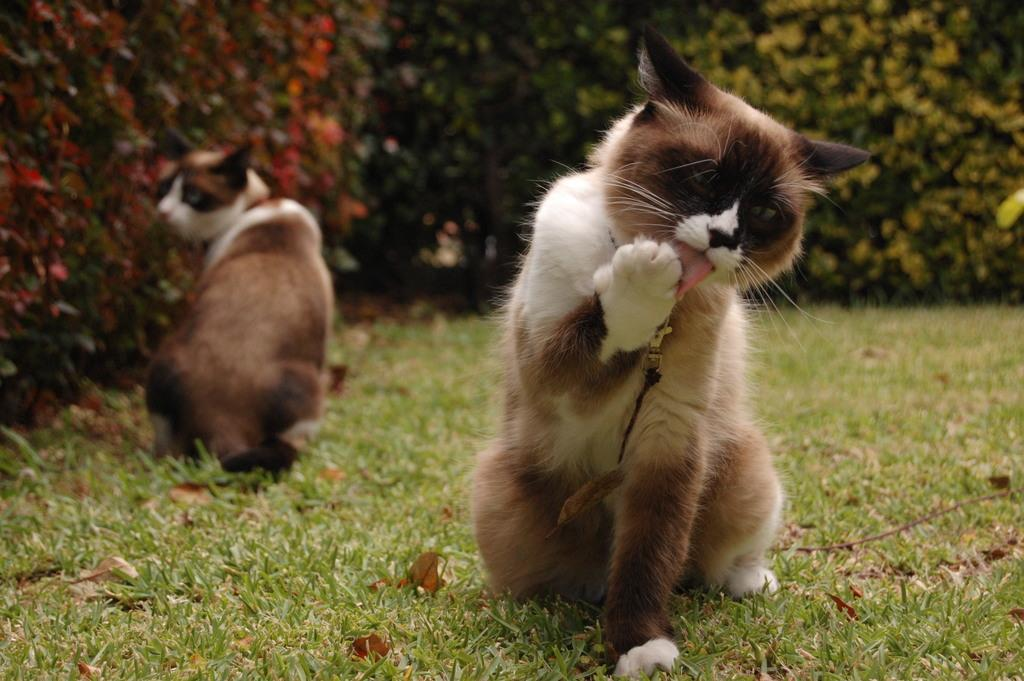What animals can be seen on the ground in the image? There are two cats on the ground in the image. What can be seen in the background of the image? Plants are visible in the background of the image. What else is present on the ground besides the cats? There are leaves on the ground. What type of verse can be heard being recited by the dolls in the image? There are no dolls present in the image, so there is no verse being recited. 